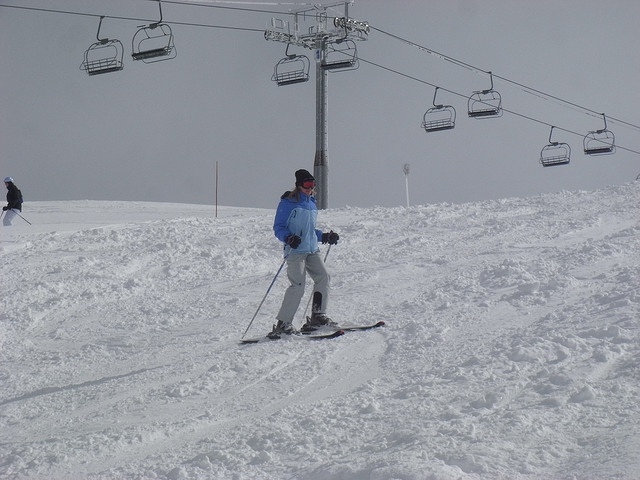Describe the objects in this image and their specific colors. I can see people in gray, black, and navy tones, people in gray, black, and darkgray tones, and skis in gray, darkgray, and black tones in this image. 